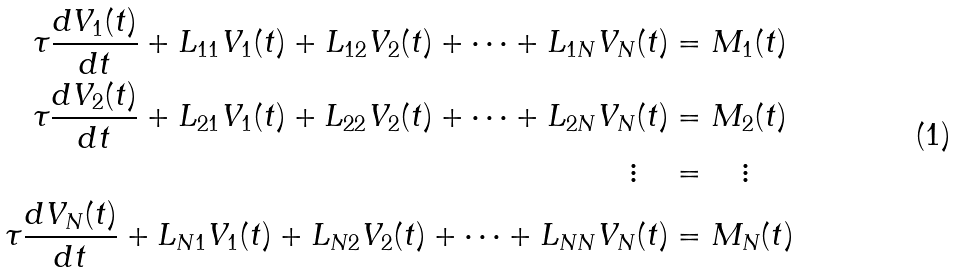Convert formula to latex. <formula><loc_0><loc_0><loc_500><loc_500>\tau \frac { d V _ { 1 } ( t ) } { d t } + L _ { 1 1 } V _ { 1 } ( t ) + L _ { 1 2 } V _ { 2 } ( t ) + \cdots + L _ { 1 N } V _ { N } ( t ) & = M _ { 1 } ( t ) \\ \tau \frac { d V _ { 2 } ( t ) } { d t } + L _ { 2 1 } V _ { 1 } ( t ) + L _ { 2 2 } V _ { 2 } ( t ) + \cdots + L _ { 2 N } V _ { N } ( t ) & = M _ { 2 } ( t ) \\ \vdots \quad & = \quad \vdots \\ \tau \frac { d V _ { N } ( t ) } { d t } + L _ { N 1 } V _ { 1 } ( t ) + L _ { N 2 } V _ { 2 } ( t ) + \cdots + L _ { N N } V _ { N } ( t ) & = M _ { N } ( t )</formula> 